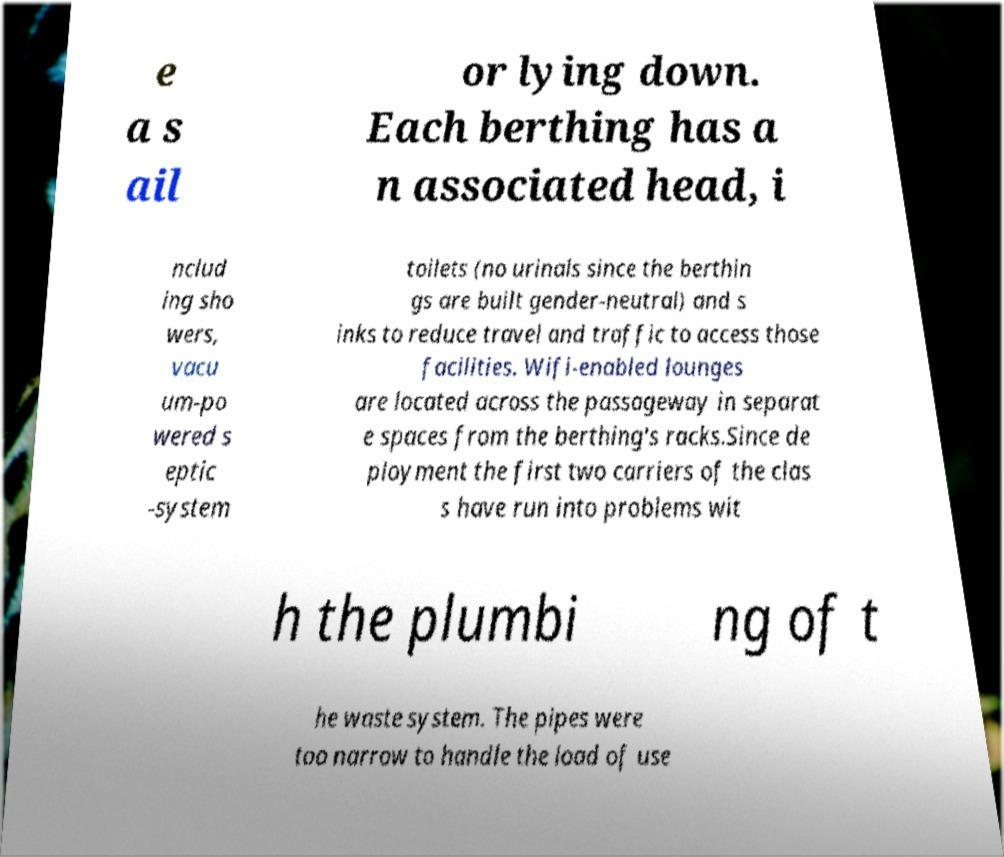I need the written content from this picture converted into text. Can you do that? e a s ail or lying down. Each berthing has a n associated head, i nclud ing sho wers, vacu um-po wered s eptic -system toilets (no urinals since the berthin gs are built gender-neutral) and s inks to reduce travel and traffic to access those facilities. Wifi-enabled lounges are located across the passageway in separat e spaces from the berthing's racks.Since de ployment the first two carriers of the clas s have run into problems wit h the plumbi ng of t he waste system. The pipes were too narrow to handle the load of use 